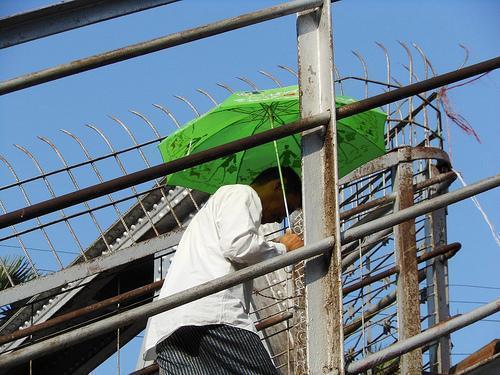How many steel poles are painted orange in this image?
Give a very brief answer. 0. 